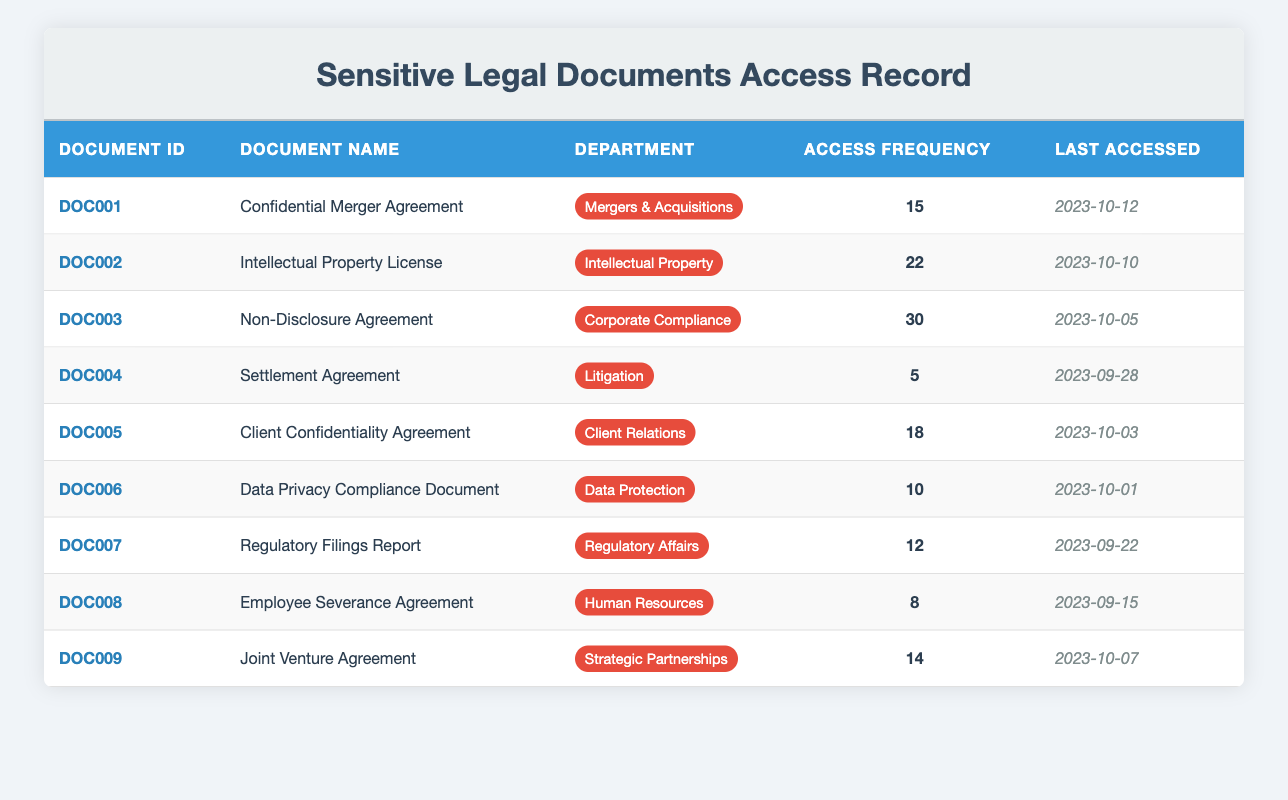What is the most accessed document? The highest access frequency in the table is 30 for the "Non-Disclosure Agreement."
Answer: Non-Disclosure Agreement Which department accessed the "Intellectual Property License" the most? The department associated with the "Intellectual Property License" is "Intellectual Property," which has an access frequency of 22.
Answer: Intellectual Property How many times the "Settlement Agreement" was accessed? The access frequency for the "Settlement Agreement" is listed as 5.
Answer: 5 What is the access frequency for the document "Client Confidentiality Agreement"? The "Client Confidentiality Agreement" has an access frequency of 18.
Answer: 18 Which document was last accessed on 2023-10-01? Referring to the table, the document last accessed on that date is the "Data Privacy Compliance Document."
Answer: Data Privacy Compliance Document What is the average access frequency of all documents? The sum of access frequencies is (15 + 22 + 30 + 5 + 18 + 10 + 12 + 8 + 14) = 134. There are 9 documents, so the average is 134 / 9 ≈ 14.89.
Answer: Approximately 14.89 Is the access frequency of "Regulatory Filings Report" greater than 15? "Regulatory Filings Report" has an access frequency of 12, which is less than 15.
Answer: No Which document has the least access frequency and what is that frequency? The "Settlement Agreement" has the least access frequency at 5.
Answer: 5 How many documents belong to the "Human Resources" department? There is one document, the "Employee Severance Agreement," under the "Human Resources" department.
Answer: 1 What is the total access frequency of documents from the "Corporate Compliance" and "Litigation" departments? The "Non-Disclosure Agreement" from "Corporate Compliance" has 30 accesses, and the "Settlement Agreement" from "Litigation" has 5, totaling 30 + 5 = 35.
Answer: 35 